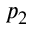<formula> <loc_0><loc_0><loc_500><loc_500>p _ { 2 }</formula> 